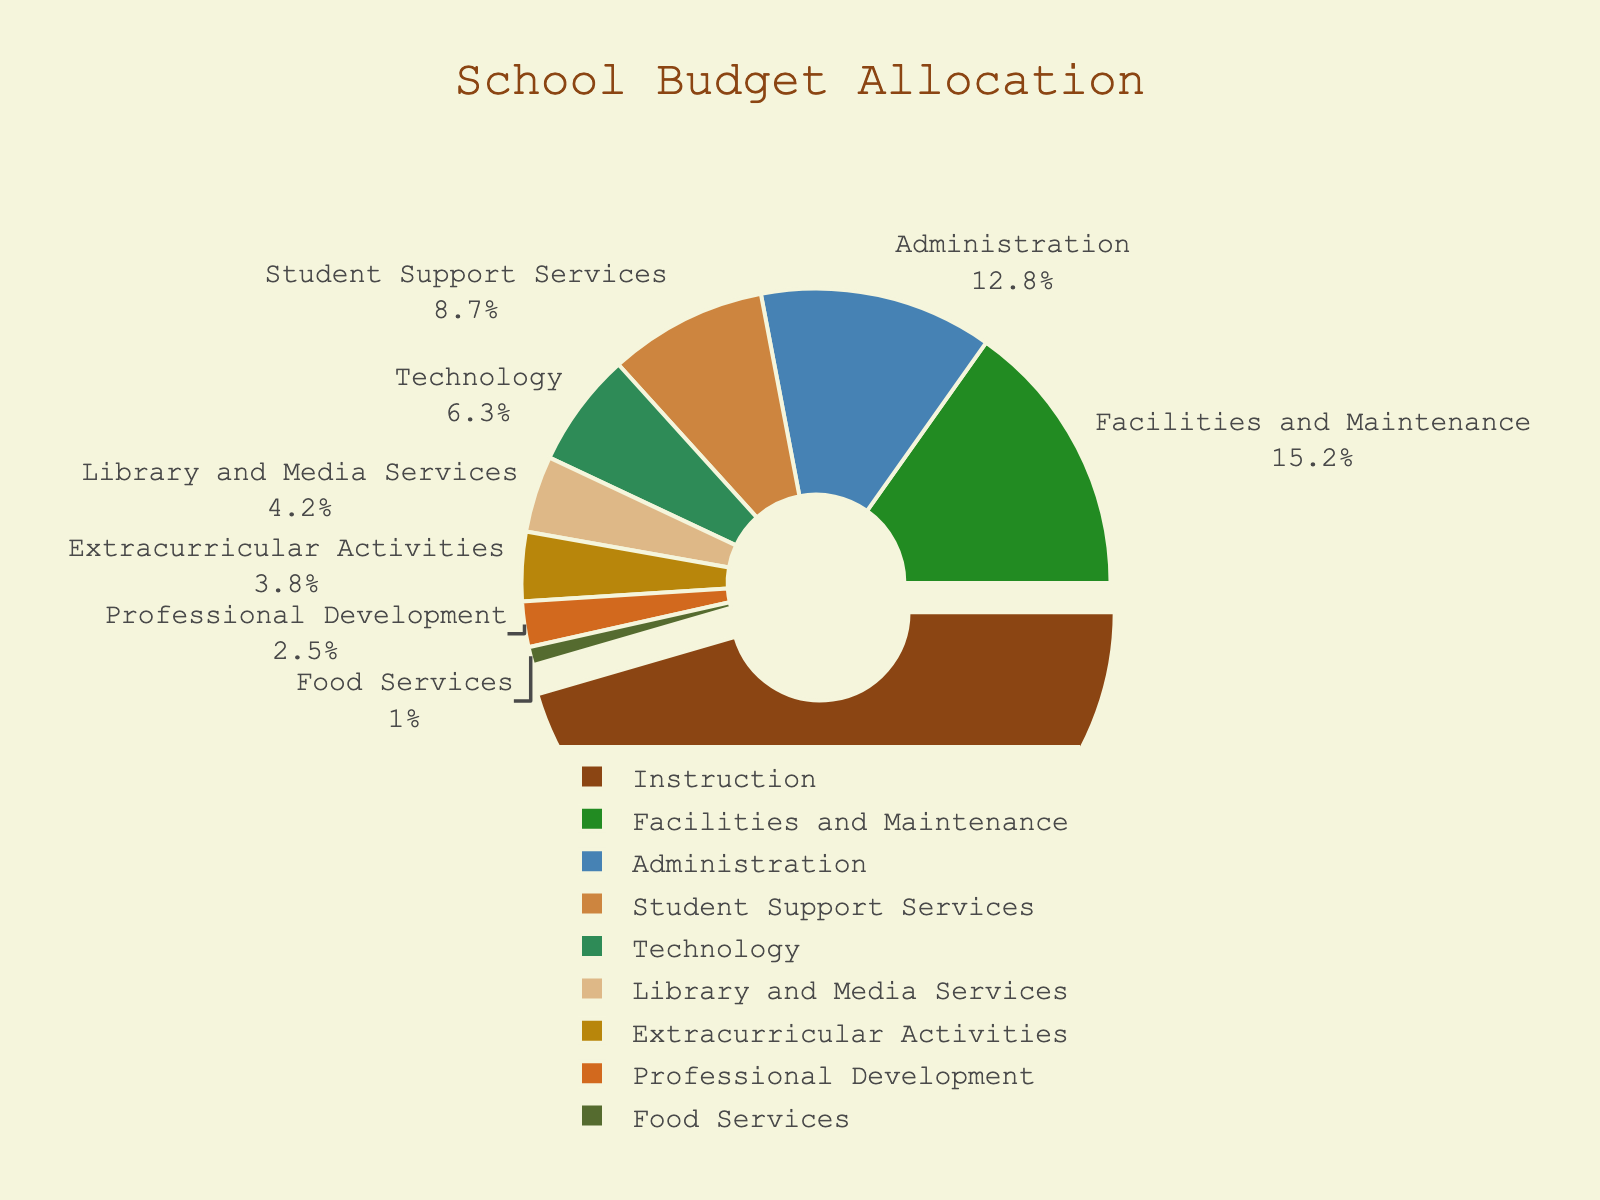Which department receives the highest percentage of the school budget? The pie chart shows each department's budget allocation as a percentage. The Instruction department occupies the largest portion of the pie chart.
Answer: Instruction How much more is allocated to Facilities and Maintenance compared to Food Services? Facilities and Maintenance is allocated 15.2% of the budget and Food Services is allocated 1.0%. Subtract 1.0% from 15.2% to find the difference.
Answer: 14.2% What is the combined budget percentage for Technology and Library and Media Services? Technology is allocated 6.3% and Library and Media Services is allocated 4.2%. Adding these together gives 6.3% + 4.2% = 10.5%.
Answer: 10.5% Which department gets fewer funds, Extracurricular Activities or Professional Development? By looking at the pie chart, Extracurricular Activities is allocated 3.8%, while Professional Development is allocated 2.5%. Since 2.5% is less than 3.8%, Professional Development gets fewer funds.
Answer: Professional Development What percentage of the budget is allocated to Student Support Services? Observe the relevant segment in the pie chart labeled Student Support Services, which shows it is allocated 8.7% of the budget.
Answer: 8.7% How does the budget percentage for Administration compare to that for Facilities and Maintenance? Referencing the pie chart, Administration is allocated 12.8% and Facilities and Maintenance is allocated 15.2%. Since 15.2% is greater than 12.8%, Facilities and Maintenance receives a higher percentage than Administration.
Answer: Facilities and Maintenance receives more What is the difference in budget allocation between the highest and lowest funded departments? The highest funded department is Instruction with 45.5% and the lowest is Food Services with 1.0%. The difference is 45.5% - 1.0% = 44.5%.
Answer: 44.5% Which segment of the pie chart is marked with a pull-out effect? The pie chart uses a pull-out effect to emphasize the Instruction department segment.
Answer: Instruction Are the combined budgets for Administration and Professional Development greater than that of Instruction? Administration is 12.8% and Professional Development is 2.5%. Combined, they are 12.8% + 2.5% = 15.3%. Instruction alone is 45.5%, which is greater than 15.3%.
Answer: No, Instruction is greater 